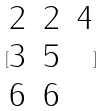Convert formula to latex. <formula><loc_0><loc_0><loc_500><loc_500>[ \begin{matrix} 2 & 2 & 4 \\ 3 & 5 \\ 6 & 6 \end{matrix} ]</formula> 